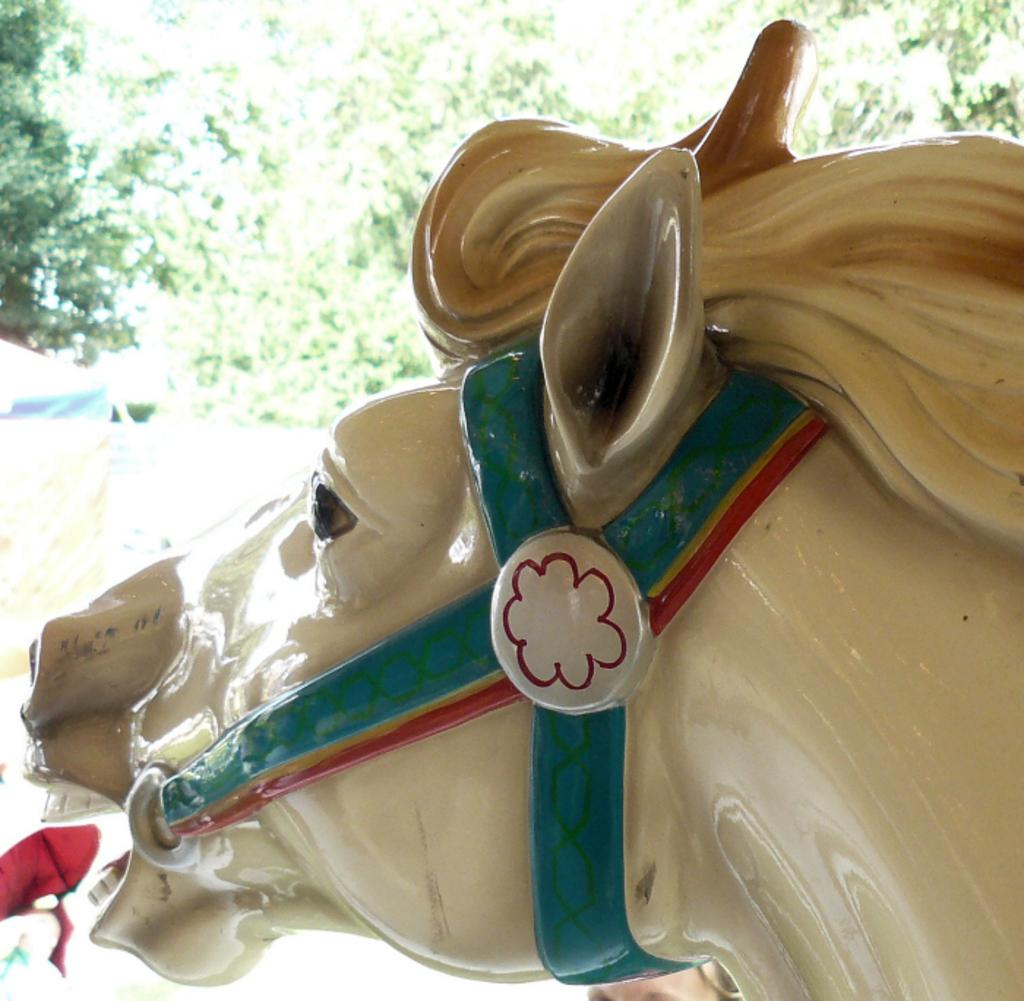What is the main subject of the image? There is a statue of a horse in the image. What can be seen in the background of the image? There are trees in the background of the image. What type of berry can be seen growing on the statue of the horse in the image? There are no berries present on the statue of the horse in the image. 